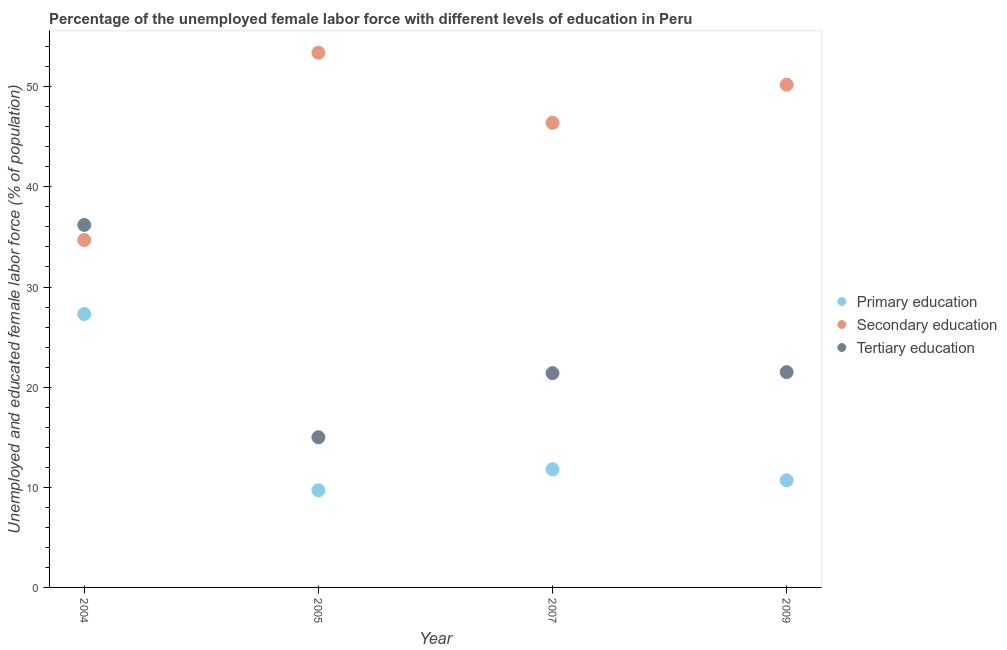How many different coloured dotlines are there?
Keep it short and to the point. 3. Is the number of dotlines equal to the number of legend labels?
Give a very brief answer. Yes. What is the percentage of female labor force who received primary education in 2004?
Offer a terse response. 27.3. Across all years, what is the maximum percentage of female labor force who received primary education?
Give a very brief answer. 27.3. Across all years, what is the minimum percentage of female labor force who received tertiary education?
Give a very brief answer. 15. In which year was the percentage of female labor force who received secondary education maximum?
Give a very brief answer. 2005. What is the total percentage of female labor force who received secondary education in the graph?
Provide a succinct answer. 184.7. What is the difference between the percentage of female labor force who received primary education in 2007 and that in 2009?
Give a very brief answer. 1.1. What is the difference between the percentage of female labor force who received primary education in 2005 and the percentage of female labor force who received secondary education in 2009?
Provide a short and direct response. -40.5. What is the average percentage of female labor force who received tertiary education per year?
Ensure brevity in your answer.  23.53. In the year 2004, what is the difference between the percentage of female labor force who received secondary education and percentage of female labor force who received primary education?
Offer a terse response. 7.4. What is the ratio of the percentage of female labor force who received tertiary education in 2004 to that in 2005?
Your response must be concise. 2.41. Is the difference between the percentage of female labor force who received primary education in 2007 and 2009 greater than the difference between the percentage of female labor force who received secondary education in 2007 and 2009?
Keep it short and to the point. Yes. What is the difference between the highest and the second highest percentage of female labor force who received secondary education?
Your answer should be compact. 3.2. What is the difference between the highest and the lowest percentage of female labor force who received tertiary education?
Give a very brief answer. 21.2. Is the sum of the percentage of female labor force who received tertiary education in 2005 and 2007 greater than the maximum percentage of female labor force who received secondary education across all years?
Your answer should be compact. No. Is it the case that in every year, the sum of the percentage of female labor force who received primary education and percentage of female labor force who received secondary education is greater than the percentage of female labor force who received tertiary education?
Give a very brief answer. Yes. Is the percentage of female labor force who received tertiary education strictly less than the percentage of female labor force who received secondary education over the years?
Give a very brief answer. No. How many dotlines are there?
Offer a terse response. 3. Does the graph contain grids?
Your answer should be compact. No. How many legend labels are there?
Make the answer very short. 3. What is the title of the graph?
Offer a very short reply. Percentage of the unemployed female labor force with different levels of education in Peru. What is the label or title of the Y-axis?
Your answer should be compact. Unemployed and educated female labor force (% of population). What is the Unemployed and educated female labor force (% of population) in Primary education in 2004?
Provide a succinct answer. 27.3. What is the Unemployed and educated female labor force (% of population) of Secondary education in 2004?
Ensure brevity in your answer.  34.7. What is the Unemployed and educated female labor force (% of population) of Tertiary education in 2004?
Keep it short and to the point. 36.2. What is the Unemployed and educated female labor force (% of population) in Primary education in 2005?
Keep it short and to the point. 9.7. What is the Unemployed and educated female labor force (% of population) of Secondary education in 2005?
Your response must be concise. 53.4. What is the Unemployed and educated female labor force (% of population) of Primary education in 2007?
Make the answer very short. 11.8. What is the Unemployed and educated female labor force (% of population) in Secondary education in 2007?
Offer a very short reply. 46.4. What is the Unemployed and educated female labor force (% of population) of Tertiary education in 2007?
Your response must be concise. 21.4. What is the Unemployed and educated female labor force (% of population) of Primary education in 2009?
Provide a succinct answer. 10.7. What is the Unemployed and educated female labor force (% of population) in Secondary education in 2009?
Offer a very short reply. 50.2. Across all years, what is the maximum Unemployed and educated female labor force (% of population) of Primary education?
Your response must be concise. 27.3. Across all years, what is the maximum Unemployed and educated female labor force (% of population) of Secondary education?
Your response must be concise. 53.4. Across all years, what is the maximum Unemployed and educated female labor force (% of population) in Tertiary education?
Keep it short and to the point. 36.2. Across all years, what is the minimum Unemployed and educated female labor force (% of population) in Primary education?
Make the answer very short. 9.7. Across all years, what is the minimum Unemployed and educated female labor force (% of population) in Secondary education?
Your response must be concise. 34.7. Across all years, what is the minimum Unemployed and educated female labor force (% of population) in Tertiary education?
Keep it short and to the point. 15. What is the total Unemployed and educated female labor force (% of population) in Primary education in the graph?
Provide a succinct answer. 59.5. What is the total Unemployed and educated female labor force (% of population) of Secondary education in the graph?
Offer a terse response. 184.7. What is the total Unemployed and educated female labor force (% of population) of Tertiary education in the graph?
Your answer should be compact. 94.1. What is the difference between the Unemployed and educated female labor force (% of population) in Secondary education in 2004 and that in 2005?
Provide a short and direct response. -18.7. What is the difference between the Unemployed and educated female labor force (% of population) in Tertiary education in 2004 and that in 2005?
Give a very brief answer. 21.2. What is the difference between the Unemployed and educated female labor force (% of population) in Tertiary education in 2004 and that in 2007?
Make the answer very short. 14.8. What is the difference between the Unemployed and educated female labor force (% of population) of Secondary education in 2004 and that in 2009?
Give a very brief answer. -15.5. What is the difference between the Unemployed and educated female labor force (% of population) of Tertiary education in 2004 and that in 2009?
Your answer should be compact. 14.7. What is the difference between the Unemployed and educated female labor force (% of population) of Primary education in 2005 and that in 2007?
Make the answer very short. -2.1. What is the difference between the Unemployed and educated female labor force (% of population) in Secondary education in 2005 and that in 2007?
Your response must be concise. 7. What is the difference between the Unemployed and educated female labor force (% of population) of Tertiary education in 2005 and that in 2007?
Your answer should be very brief. -6.4. What is the difference between the Unemployed and educated female labor force (% of population) in Primary education in 2005 and that in 2009?
Offer a very short reply. -1. What is the difference between the Unemployed and educated female labor force (% of population) in Secondary education in 2005 and that in 2009?
Your answer should be very brief. 3.2. What is the difference between the Unemployed and educated female labor force (% of population) in Tertiary education in 2005 and that in 2009?
Offer a very short reply. -6.5. What is the difference between the Unemployed and educated female labor force (% of population) in Primary education in 2007 and that in 2009?
Offer a terse response. 1.1. What is the difference between the Unemployed and educated female labor force (% of population) in Secondary education in 2007 and that in 2009?
Offer a terse response. -3.8. What is the difference between the Unemployed and educated female labor force (% of population) in Primary education in 2004 and the Unemployed and educated female labor force (% of population) in Secondary education in 2005?
Your answer should be compact. -26.1. What is the difference between the Unemployed and educated female labor force (% of population) of Primary education in 2004 and the Unemployed and educated female labor force (% of population) of Tertiary education in 2005?
Your answer should be compact. 12.3. What is the difference between the Unemployed and educated female labor force (% of population) in Secondary education in 2004 and the Unemployed and educated female labor force (% of population) in Tertiary education in 2005?
Give a very brief answer. 19.7. What is the difference between the Unemployed and educated female labor force (% of population) in Primary education in 2004 and the Unemployed and educated female labor force (% of population) in Secondary education in 2007?
Make the answer very short. -19.1. What is the difference between the Unemployed and educated female labor force (% of population) in Primary education in 2004 and the Unemployed and educated female labor force (% of population) in Tertiary education in 2007?
Ensure brevity in your answer.  5.9. What is the difference between the Unemployed and educated female labor force (% of population) in Primary education in 2004 and the Unemployed and educated female labor force (% of population) in Secondary education in 2009?
Offer a very short reply. -22.9. What is the difference between the Unemployed and educated female labor force (% of population) in Primary education in 2004 and the Unemployed and educated female labor force (% of population) in Tertiary education in 2009?
Ensure brevity in your answer.  5.8. What is the difference between the Unemployed and educated female labor force (% of population) of Primary education in 2005 and the Unemployed and educated female labor force (% of population) of Secondary education in 2007?
Provide a succinct answer. -36.7. What is the difference between the Unemployed and educated female labor force (% of population) in Primary education in 2005 and the Unemployed and educated female labor force (% of population) in Tertiary education in 2007?
Your answer should be compact. -11.7. What is the difference between the Unemployed and educated female labor force (% of population) in Secondary education in 2005 and the Unemployed and educated female labor force (% of population) in Tertiary education in 2007?
Offer a terse response. 32. What is the difference between the Unemployed and educated female labor force (% of population) of Primary education in 2005 and the Unemployed and educated female labor force (% of population) of Secondary education in 2009?
Make the answer very short. -40.5. What is the difference between the Unemployed and educated female labor force (% of population) in Secondary education in 2005 and the Unemployed and educated female labor force (% of population) in Tertiary education in 2009?
Offer a terse response. 31.9. What is the difference between the Unemployed and educated female labor force (% of population) in Primary education in 2007 and the Unemployed and educated female labor force (% of population) in Secondary education in 2009?
Provide a succinct answer. -38.4. What is the difference between the Unemployed and educated female labor force (% of population) of Secondary education in 2007 and the Unemployed and educated female labor force (% of population) of Tertiary education in 2009?
Your answer should be compact. 24.9. What is the average Unemployed and educated female labor force (% of population) in Primary education per year?
Provide a short and direct response. 14.88. What is the average Unemployed and educated female labor force (% of population) of Secondary education per year?
Make the answer very short. 46.17. What is the average Unemployed and educated female labor force (% of population) of Tertiary education per year?
Your response must be concise. 23.52. In the year 2004, what is the difference between the Unemployed and educated female labor force (% of population) of Primary education and Unemployed and educated female labor force (% of population) of Tertiary education?
Keep it short and to the point. -8.9. In the year 2004, what is the difference between the Unemployed and educated female labor force (% of population) in Secondary education and Unemployed and educated female labor force (% of population) in Tertiary education?
Offer a very short reply. -1.5. In the year 2005, what is the difference between the Unemployed and educated female labor force (% of population) in Primary education and Unemployed and educated female labor force (% of population) in Secondary education?
Give a very brief answer. -43.7. In the year 2005, what is the difference between the Unemployed and educated female labor force (% of population) in Secondary education and Unemployed and educated female labor force (% of population) in Tertiary education?
Give a very brief answer. 38.4. In the year 2007, what is the difference between the Unemployed and educated female labor force (% of population) of Primary education and Unemployed and educated female labor force (% of population) of Secondary education?
Offer a very short reply. -34.6. In the year 2007, what is the difference between the Unemployed and educated female labor force (% of population) of Primary education and Unemployed and educated female labor force (% of population) of Tertiary education?
Provide a succinct answer. -9.6. In the year 2007, what is the difference between the Unemployed and educated female labor force (% of population) of Secondary education and Unemployed and educated female labor force (% of population) of Tertiary education?
Your answer should be compact. 25. In the year 2009, what is the difference between the Unemployed and educated female labor force (% of population) of Primary education and Unemployed and educated female labor force (% of population) of Secondary education?
Ensure brevity in your answer.  -39.5. In the year 2009, what is the difference between the Unemployed and educated female labor force (% of population) in Secondary education and Unemployed and educated female labor force (% of population) in Tertiary education?
Keep it short and to the point. 28.7. What is the ratio of the Unemployed and educated female labor force (% of population) in Primary education in 2004 to that in 2005?
Offer a very short reply. 2.81. What is the ratio of the Unemployed and educated female labor force (% of population) in Secondary education in 2004 to that in 2005?
Your answer should be compact. 0.65. What is the ratio of the Unemployed and educated female labor force (% of population) of Tertiary education in 2004 to that in 2005?
Your answer should be compact. 2.41. What is the ratio of the Unemployed and educated female labor force (% of population) of Primary education in 2004 to that in 2007?
Give a very brief answer. 2.31. What is the ratio of the Unemployed and educated female labor force (% of population) in Secondary education in 2004 to that in 2007?
Offer a terse response. 0.75. What is the ratio of the Unemployed and educated female labor force (% of population) of Tertiary education in 2004 to that in 2007?
Give a very brief answer. 1.69. What is the ratio of the Unemployed and educated female labor force (% of population) of Primary education in 2004 to that in 2009?
Your response must be concise. 2.55. What is the ratio of the Unemployed and educated female labor force (% of population) of Secondary education in 2004 to that in 2009?
Offer a very short reply. 0.69. What is the ratio of the Unemployed and educated female labor force (% of population) of Tertiary education in 2004 to that in 2009?
Provide a short and direct response. 1.68. What is the ratio of the Unemployed and educated female labor force (% of population) of Primary education in 2005 to that in 2007?
Offer a terse response. 0.82. What is the ratio of the Unemployed and educated female labor force (% of population) of Secondary education in 2005 to that in 2007?
Offer a terse response. 1.15. What is the ratio of the Unemployed and educated female labor force (% of population) of Tertiary education in 2005 to that in 2007?
Your answer should be very brief. 0.7. What is the ratio of the Unemployed and educated female labor force (% of population) in Primary education in 2005 to that in 2009?
Offer a terse response. 0.91. What is the ratio of the Unemployed and educated female labor force (% of population) in Secondary education in 2005 to that in 2009?
Offer a very short reply. 1.06. What is the ratio of the Unemployed and educated female labor force (% of population) in Tertiary education in 2005 to that in 2009?
Your answer should be very brief. 0.7. What is the ratio of the Unemployed and educated female labor force (% of population) of Primary education in 2007 to that in 2009?
Your answer should be compact. 1.1. What is the ratio of the Unemployed and educated female labor force (% of population) in Secondary education in 2007 to that in 2009?
Provide a succinct answer. 0.92. What is the difference between the highest and the lowest Unemployed and educated female labor force (% of population) of Secondary education?
Provide a succinct answer. 18.7. What is the difference between the highest and the lowest Unemployed and educated female labor force (% of population) in Tertiary education?
Make the answer very short. 21.2. 